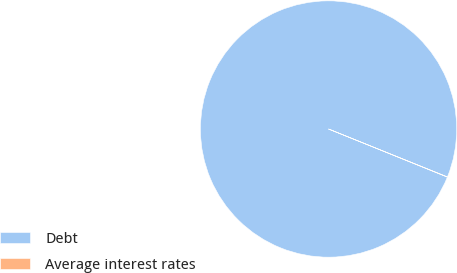Convert chart to OTSL. <chart><loc_0><loc_0><loc_500><loc_500><pie_chart><fcel>Debt<fcel>Average interest rates<nl><fcel>99.97%<fcel>0.03%<nl></chart> 